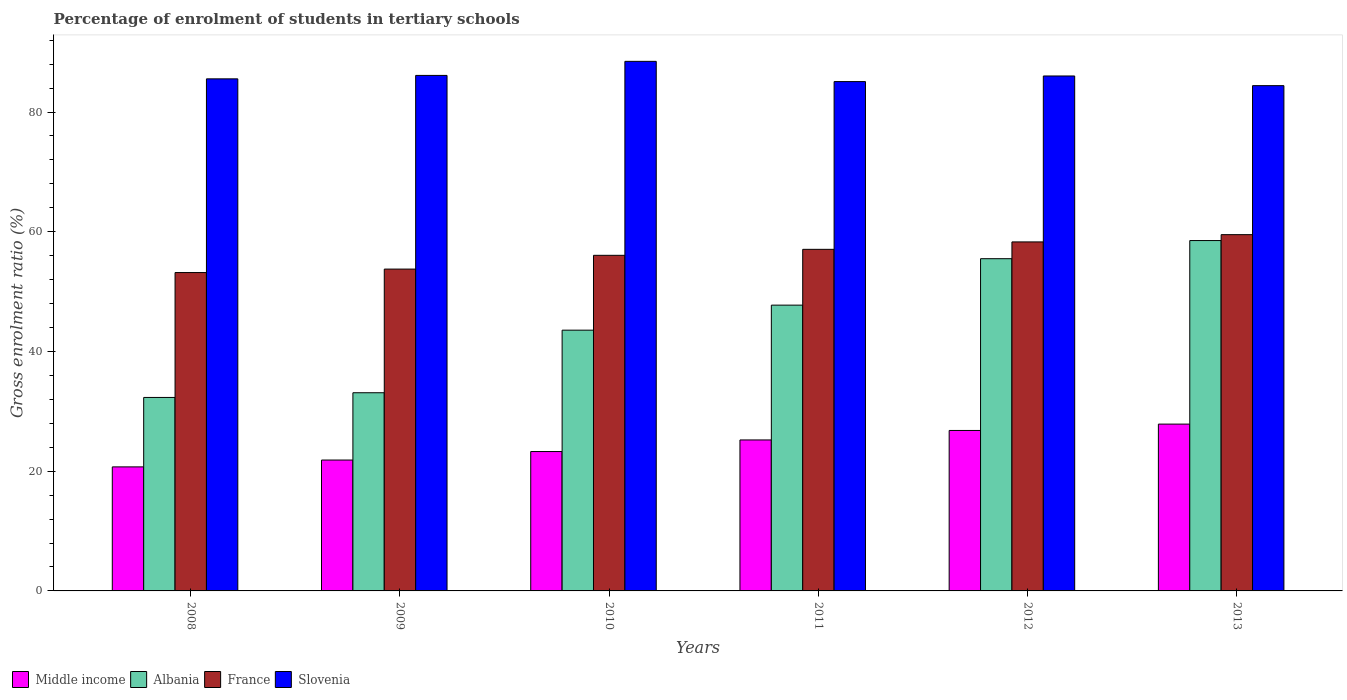How many different coloured bars are there?
Offer a terse response. 4. Are the number of bars per tick equal to the number of legend labels?
Offer a terse response. Yes. Are the number of bars on each tick of the X-axis equal?
Offer a very short reply. Yes. How many bars are there on the 2nd tick from the right?
Provide a short and direct response. 4. What is the label of the 6th group of bars from the left?
Make the answer very short. 2013. What is the percentage of students enrolled in tertiary schools in France in 2012?
Ensure brevity in your answer.  58.3. Across all years, what is the maximum percentage of students enrolled in tertiary schools in Middle income?
Offer a very short reply. 27.87. Across all years, what is the minimum percentage of students enrolled in tertiary schools in France?
Your answer should be very brief. 53.19. What is the total percentage of students enrolled in tertiary schools in Slovenia in the graph?
Give a very brief answer. 515.66. What is the difference between the percentage of students enrolled in tertiary schools in Middle income in 2011 and that in 2013?
Your response must be concise. -2.64. What is the difference between the percentage of students enrolled in tertiary schools in France in 2008 and the percentage of students enrolled in tertiary schools in Middle income in 2013?
Provide a succinct answer. 25.32. What is the average percentage of students enrolled in tertiary schools in Slovenia per year?
Your response must be concise. 85.94. In the year 2013, what is the difference between the percentage of students enrolled in tertiary schools in Albania and percentage of students enrolled in tertiary schools in France?
Ensure brevity in your answer.  -0.99. What is the ratio of the percentage of students enrolled in tertiary schools in Middle income in 2010 to that in 2012?
Provide a succinct answer. 0.87. Is the percentage of students enrolled in tertiary schools in Middle income in 2010 less than that in 2012?
Give a very brief answer. Yes. Is the difference between the percentage of students enrolled in tertiary schools in Albania in 2011 and 2013 greater than the difference between the percentage of students enrolled in tertiary schools in France in 2011 and 2013?
Provide a short and direct response. No. What is the difference between the highest and the second highest percentage of students enrolled in tertiary schools in France?
Your answer should be compact. 1.21. What is the difference between the highest and the lowest percentage of students enrolled in tertiary schools in Albania?
Your answer should be very brief. 26.21. In how many years, is the percentage of students enrolled in tertiary schools in France greater than the average percentage of students enrolled in tertiary schools in France taken over all years?
Your answer should be compact. 3. Is the sum of the percentage of students enrolled in tertiary schools in Middle income in 2010 and 2011 greater than the maximum percentage of students enrolled in tertiary schools in Slovenia across all years?
Provide a succinct answer. No. What does the 2nd bar from the left in 2013 represents?
Provide a short and direct response. Albania. What does the 4th bar from the right in 2012 represents?
Make the answer very short. Middle income. How many bars are there?
Offer a terse response. 24. Does the graph contain any zero values?
Provide a succinct answer. No. Does the graph contain grids?
Your response must be concise. No. Where does the legend appear in the graph?
Offer a terse response. Bottom left. How many legend labels are there?
Provide a short and direct response. 4. What is the title of the graph?
Provide a succinct answer. Percentage of enrolment of students in tertiary schools. Does "Qatar" appear as one of the legend labels in the graph?
Keep it short and to the point. No. What is the label or title of the Y-axis?
Offer a very short reply. Gross enrolment ratio (%). What is the Gross enrolment ratio (%) in Middle income in 2008?
Keep it short and to the point. 20.72. What is the Gross enrolment ratio (%) of Albania in 2008?
Keep it short and to the point. 32.32. What is the Gross enrolment ratio (%) of France in 2008?
Provide a short and direct response. 53.19. What is the Gross enrolment ratio (%) in Slovenia in 2008?
Provide a succinct answer. 85.55. What is the Gross enrolment ratio (%) in Middle income in 2009?
Offer a terse response. 21.86. What is the Gross enrolment ratio (%) of Albania in 2009?
Make the answer very short. 33.11. What is the Gross enrolment ratio (%) in France in 2009?
Offer a terse response. 53.76. What is the Gross enrolment ratio (%) of Slovenia in 2009?
Offer a very short reply. 86.12. What is the Gross enrolment ratio (%) in Middle income in 2010?
Keep it short and to the point. 23.28. What is the Gross enrolment ratio (%) of Albania in 2010?
Ensure brevity in your answer.  43.56. What is the Gross enrolment ratio (%) of France in 2010?
Offer a very short reply. 56.06. What is the Gross enrolment ratio (%) of Slovenia in 2010?
Provide a short and direct response. 88.47. What is the Gross enrolment ratio (%) of Middle income in 2011?
Provide a short and direct response. 25.22. What is the Gross enrolment ratio (%) in Albania in 2011?
Provide a succinct answer. 47.74. What is the Gross enrolment ratio (%) in France in 2011?
Provide a short and direct response. 57.06. What is the Gross enrolment ratio (%) in Slovenia in 2011?
Give a very brief answer. 85.09. What is the Gross enrolment ratio (%) in Middle income in 2012?
Provide a succinct answer. 26.81. What is the Gross enrolment ratio (%) in Albania in 2012?
Your response must be concise. 55.5. What is the Gross enrolment ratio (%) in France in 2012?
Your response must be concise. 58.3. What is the Gross enrolment ratio (%) in Slovenia in 2012?
Provide a succinct answer. 86.02. What is the Gross enrolment ratio (%) in Middle income in 2013?
Your response must be concise. 27.87. What is the Gross enrolment ratio (%) of Albania in 2013?
Make the answer very short. 58.53. What is the Gross enrolment ratio (%) of France in 2013?
Offer a terse response. 59.52. What is the Gross enrolment ratio (%) in Slovenia in 2013?
Keep it short and to the point. 84.41. Across all years, what is the maximum Gross enrolment ratio (%) of Middle income?
Your answer should be very brief. 27.87. Across all years, what is the maximum Gross enrolment ratio (%) in Albania?
Ensure brevity in your answer.  58.53. Across all years, what is the maximum Gross enrolment ratio (%) of France?
Ensure brevity in your answer.  59.52. Across all years, what is the maximum Gross enrolment ratio (%) of Slovenia?
Offer a very short reply. 88.47. Across all years, what is the minimum Gross enrolment ratio (%) in Middle income?
Make the answer very short. 20.72. Across all years, what is the minimum Gross enrolment ratio (%) in Albania?
Offer a terse response. 32.32. Across all years, what is the minimum Gross enrolment ratio (%) of France?
Your answer should be compact. 53.19. Across all years, what is the minimum Gross enrolment ratio (%) of Slovenia?
Provide a short and direct response. 84.41. What is the total Gross enrolment ratio (%) in Middle income in the graph?
Your answer should be very brief. 145.77. What is the total Gross enrolment ratio (%) of Albania in the graph?
Your answer should be compact. 270.76. What is the total Gross enrolment ratio (%) in France in the graph?
Provide a succinct answer. 337.9. What is the total Gross enrolment ratio (%) in Slovenia in the graph?
Provide a succinct answer. 515.66. What is the difference between the Gross enrolment ratio (%) in Middle income in 2008 and that in 2009?
Your answer should be compact. -1.14. What is the difference between the Gross enrolment ratio (%) in Albania in 2008 and that in 2009?
Offer a very short reply. -0.78. What is the difference between the Gross enrolment ratio (%) of France in 2008 and that in 2009?
Keep it short and to the point. -0.58. What is the difference between the Gross enrolment ratio (%) in Slovenia in 2008 and that in 2009?
Make the answer very short. -0.57. What is the difference between the Gross enrolment ratio (%) of Middle income in 2008 and that in 2010?
Make the answer very short. -2.56. What is the difference between the Gross enrolment ratio (%) in Albania in 2008 and that in 2010?
Give a very brief answer. -11.24. What is the difference between the Gross enrolment ratio (%) of France in 2008 and that in 2010?
Provide a succinct answer. -2.88. What is the difference between the Gross enrolment ratio (%) of Slovenia in 2008 and that in 2010?
Ensure brevity in your answer.  -2.92. What is the difference between the Gross enrolment ratio (%) of Middle income in 2008 and that in 2011?
Your answer should be very brief. -4.5. What is the difference between the Gross enrolment ratio (%) in Albania in 2008 and that in 2011?
Make the answer very short. -15.42. What is the difference between the Gross enrolment ratio (%) in France in 2008 and that in 2011?
Offer a very short reply. -3.88. What is the difference between the Gross enrolment ratio (%) of Slovenia in 2008 and that in 2011?
Provide a succinct answer. 0.46. What is the difference between the Gross enrolment ratio (%) in Middle income in 2008 and that in 2012?
Provide a short and direct response. -6.09. What is the difference between the Gross enrolment ratio (%) of Albania in 2008 and that in 2012?
Your response must be concise. -23.18. What is the difference between the Gross enrolment ratio (%) in France in 2008 and that in 2012?
Keep it short and to the point. -5.12. What is the difference between the Gross enrolment ratio (%) in Slovenia in 2008 and that in 2012?
Ensure brevity in your answer.  -0.48. What is the difference between the Gross enrolment ratio (%) of Middle income in 2008 and that in 2013?
Your response must be concise. -7.15. What is the difference between the Gross enrolment ratio (%) in Albania in 2008 and that in 2013?
Your answer should be very brief. -26.21. What is the difference between the Gross enrolment ratio (%) in France in 2008 and that in 2013?
Provide a succinct answer. -6.33. What is the difference between the Gross enrolment ratio (%) of Slovenia in 2008 and that in 2013?
Ensure brevity in your answer.  1.14. What is the difference between the Gross enrolment ratio (%) of Middle income in 2009 and that in 2010?
Give a very brief answer. -1.42. What is the difference between the Gross enrolment ratio (%) in Albania in 2009 and that in 2010?
Keep it short and to the point. -10.46. What is the difference between the Gross enrolment ratio (%) of France in 2009 and that in 2010?
Make the answer very short. -2.3. What is the difference between the Gross enrolment ratio (%) in Slovenia in 2009 and that in 2010?
Make the answer very short. -2.35. What is the difference between the Gross enrolment ratio (%) in Middle income in 2009 and that in 2011?
Provide a short and direct response. -3.36. What is the difference between the Gross enrolment ratio (%) in Albania in 2009 and that in 2011?
Your response must be concise. -14.64. What is the difference between the Gross enrolment ratio (%) in France in 2009 and that in 2011?
Offer a very short reply. -3.3. What is the difference between the Gross enrolment ratio (%) of Slovenia in 2009 and that in 2011?
Your response must be concise. 1.03. What is the difference between the Gross enrolment ratio (%) of Middle income in 2009 and that in 2012?
Offer a very short reply. -4.94. What is the difference between the Gross enrolment ratio (%) in Albania in 2009 and that in 2012?
Your response must be concise. -22.39. What is the difference between the Gross enrolment ratio (%) in France in 2009 and that in 2012?
Your answer should be very brief. -4.54. What is the difference between the Gross enrolment ratio (%) in Slovenia in 2009 and that in 2012?
Your answer should be compact. 0.09. What is the difference between the Gross enrolment ratio (%) in Middle income in 2009 and that in 2013?
Ensure brevity in your answer.  -6. What is the difference between the Gross enrolment ratio (%) in Albania in 2009 and that in 2013?
Make the answer very short. -25.42. What is the difference between the Gross enrolment ratio (%) of France in 2009 and that in 2013?
Your response must be concise. -5.75. What is the difference between the Gross enrolment ratio (%) of Slovenia in 2009 and that in 2013?
Offer a terse response. 1.71. What is the difference between the Gross enrolment ratio (%) of Middle income in 2010 and that in 2011?
Offer a very short reply. -1.94. What is the difference between the Gross enrolment ratio (%) in Albania in 2010 and that in 2011?
Offer a terse response. -4.18. What is the difference between the Gross enrolment ratio (%) in France in 2010 and that in 2011?
Keep it short and to the point. -1. What is the difference between the Gross enrolment ratio (%) in Slovenia in 2010 and that in 2011?
Make the answer very short. 3.38. What is the difference between the Gross enrolment ratio (%) of Middle income in 2010 and that in 2012?
Your answer should be compact. -3.52. What is the difference between the Gross enrolment ratio (%) in Albania in 2010 and that in 2012?
Offer a terse response. -11.94. What is the difference between the Gross enrolment ratio (%) of France in 2010 and that in 2012?
Ensure brevity in your answer.  -2.24. What is the difference between the Gross enrolment ratio (%) of Slovenia in 2010 and that in 2012?
Your response must be concise. 2.44. What is the difference between the Gross enrolment ratio (%) in Middle income in 2010 and that in 2013?
Your response must be concise. -4.58. What is the difference between the Gross enrolment ratio (%) in Albania in 2010 and that in 2013?
Offer a very short reply. -14.97. What is the difference between the Gross enrolment ratio (%) of France in 2010 and that in 2013?
Your answer should be compact. -3.45. What is the difference between the Gross enrolment ratio (%) of Slovenia in 2010 and that in 2013?
Your response must be concise. 4.06. What is the difference between the Gross enrolment ratio (%) of Middle income in 2011 and that in 2012?
Your response must be concise. -1.58. What is the difference between the Gross enrolment ratio (%) of Albania in 2011 and that in 2012?
Offer a terse response. -7.76. What is the difference between the Gross enrolment ratio (%) of France in 2011 and that in 2012?
Offer a terse response. -1.24. What is the difference between the Gross enrolment ratio (%) in Slovenia in 2011 and that in 2012?
Offer a terse response. -0.94. What is the difference between the Gross enrolment ratio (%) of Middle income in 2011 and that in 2013?
Your answer should be very brief. -2.64. What is the difference between the Gross enrolment ratio (%) in Albania in 2011 and that in 2013?
Your response must be concise. -10.79. What is the difference between the Gross enrolment ratio (%) of France in 2011 and that in 2013?
Provide a succinct answer. -2.45. What is the difference between the Gross enrolment ratio (%) in Slovenia in 2011 and that in 2013?
Provide a short and direct response. 0.68. What is the difference between the Gross enrolment ratio (%) in Middle income in 2012 and that in 2013?
Provide a short and direct response. -1.06. What is the difference between the Gross enrolment ratio (%) of Albania in 2012 and that in 2013?
Ensure brevity in your answer.  -3.03. What is the difference between the Gross enrolment ratio (%) of France in 2012 and that in 2013?
Provide a short and direct response. -1.21. What is the difference between the Gross enrolment ratio (%) of Slovenia in 2012 and that in 2013?
Your answer should be compact. 1.61. What is the difference between the Gross enrolment ratio (%) of Middle income in 2008 and the Gross enrolment ratio (%) of Albania in 2009?
Ensure brevity in your answer.  -12.39. What is the difference between the Gross enrolment ratio (%) of Middle income in 2008 and the Gross enrolment ratio (%) of France in 2009?
Your answer should be very brief. -33.04. What is the difference between the Gross enrolment ratio (%) of Middle income in 2008 and the Gross enrolment ratio (%) of Slovenia in 2009?
Provide a short and direct response. -65.4. What is the difference between the Gross enrolment ratio (%) of Albania in 2008 and the Gross enrolment ratio (%) of France in 2009?
Ensure brevity in your answer.  -21.44. What is the difference between the Gross enrolment ratio (%) of Albania in 2008 and the Gross enrolment ratio (%) of Slovenia in 2009?
Your answer should be very brief. -53.8. What is the difference between the Gross enrolment ratio (%) of France in 2008 and the Gross enrolment ratio (%) of Slovenia in 2009?
Provide a short and direct response. -32.93. What is the difference between the Gross enrolment ratio (%) in Middle income in 2008 and the Gross enrolment ratio (%) in Albania in 2010?
Provide a short and direct response. -22.84. What is the difference between the Gross enrolment ratio (%) of Middle income in 2008 and the Gross enrolment ratio (%) of France in 2010?
Give a very brief answer. -35.34. What is the difference between the Gross enrolment ratio (%) of Middle income in 2008 and the Gross enrolment ratio (%) of Slovenia in 2010?
Provide a succinct answer. -67.75. What is the difference between the Gross enrolment ratio (%) of Albania in 2008 and the Gross enrolment ratio (%) of France in 2010?
Your answer should be very brief. -23.74. What is the difference between the Gross enrolment ratio (%) in Albania in 2008 and the Gross enrolment ratio (%) in Slovenia in 2010?
Provide a succinct answer. -56.15. What is the difference between the Gross enrolment ratio (%) in France in 2008 and the Gross enrolment ratio (%) in Slovenia in 2010?
Offer a terse response. -35.28. What is the difference between the Gross enrolment ratio (%) of Middle income in 2008 and the Gross enrolment ratio (%) of Albania in 2011?
Keep it short and to the point. -27.02. What is the difference between the Gross enrolment ratio (%) of Middle income in 2008 and the Gross enrolment ratio (%) of France in 2011?
Your response must be concise. -36.34. What is the difference between the Gross enrolment ratio (%) of Middle income in 2008 and the Gross enrolment ratio (%) of Slovenia in 2011?
Give a very brief answer. -64.37. What is the difference between the Gross enrolment ratio (%) of Albania in 2008 and the Gross enrolment ratio (%) of France in 2011?
Ensure brevity in your answer.  -24.74. What is the difference between the Gross enrolment ratio (%) in Albania in 2008 and the Gross enrolment ratio (%) in Slovenia in 2011?
Ensure brevity in your answer.  -52.77. What is the difference between the Gross enrolment ratio (%) of France in 2008 and the Gross enrolment ratio (%) of Slovenia in 2011?
Your answer should be very brief. -31.9. What is the difference between the Gross enrolment ratio (%) of Middle income in 2008 and the Gross enrolment ratio (%) of Albania in 2012?
Your response must be concise. -34.78. What is the difference between the Gross enrolment ratio (%) of Middle income in 2008 and the Gross enrolment ratio (%) of France in 2012?
Ensure brevity in your answer.  -37.58. What is the difference between the Gross enrolment ratio (%) of Middle income in 2008 and the Gross enrolment ratio (%) of Slovenia in 2012?
Provide a short and direct response. -65.3. What is the difference between the Gross enrolment ratio (%) in Albania in 2008 and the Gross enrolment ratio (%) in France in 2012?
Ensure brevity in your answer.  -25.98. What is the difference between the Gross enrolment ratio (%) of Albania in 2008 and the Gross enrolment ratio (%) of Slovenia in 2012?
Offer a very short reply. -53.7. What is the difference between the Gross enrolment ratio (%) of France in 2008 and the Gross enrolment ratio (%) of Slovenia in 2012?
Give a very brief answer. -32.84. What is the difference between the Gross enrolment ratio (%) of Middle income in 2008 and the Gross enrolment ratio (%) of Albania in 2013?
Make the answer very short. -37.81. What is the difference between the Gross enrolment ratio (%) in Middle income in 2008 and the Gross enrolment ratio (%) in France in 2013?
Your answer should be very brief. -38.8. What is the difference between the Gross enrolment ratio (%) of Middle income in 2008 and the Gross enrolment ratio (%) of Slovenia in 2013?
Give a very brief answer. -63.69. What is the difference between the Gross enrolment ratio (%) of Albania in 2008 and the Gross enrolment ratio (%) of France in 2013?
Provide a short and direct response. -27.2. What is the difference between the Gross enrolment ratio (%) of Albania in 2008 and the Gross enrolment ratio (%) of Slovenia in 2013?
Offer a terse response. -52.09. What is the difference between the Gross enrolment ratio (%) of France in 2008 and the Gross enrolment ratio (%) of Slovenia in 2013?
Your answer should be very brief. -31.22. What is the difference between the Gross enrolment ratio (%) of Middle income in 2009 and the Gross enrolment ratio (%) of Albania in 2010?
Keep it short and to the point. -21.7. What is the difference between the Gross enrolment ratio (%) of Middle income in 2009 and the Gross enrolment ratio (%) of France in 2010?
Make the answer very short. -34.2. What is the difference between the Gross enrolment ratio (%) of Middle income in 2009 and the Gross enrolment ratio (%) of Slovenia in 2010?
Ensure brevity in your answer.  -66.6. What is the difference between the Gross enrolment ratio (%) of Albania in 2009 and the Gross enrolment ratio (%) of France in 2010?
Keep it short and to the point. -22.96. What is the difference between the Gross enrolment ratio (%) in Albania in 2009 and the Gross enrolment ratio (%) in Slovenia in 2010?
Your answer should be very brief. -55.36. What is the difference between the Gross enrolment ratio (%) of France in 2009 and the Gross enrolment ratio (%) of Slovenia in 2010?
Ensure brevity in your answer.  -34.7. What is the difference between the Gross enrolment ratio (%) in Middle income in 2009 and the Gross enrolment ratio (%) in Albania in 2011?
Your answer should be compact. -25.88. What is the difference between the Gross enrolment ratio (%) in Middle income in 2009 and the Gross enrolment ratio (%) in France in 2011?
Give a very brief answer. -35.2. What is the difference between the Gross enrolment ratio (%) of Middle income in 2009 and the Gross enrolment ratio (%) of Slovenia in 2011?
Offer a very short reply. -63.22. What is the difference between the Gross enrolment ratio (%) in Albania in 2009 and the Gross enrolment ratio (%) in France in 2011?
Your response must be concise. -23.96. What is the difference between the Gross enrolment ratio (%) of Albania in 2009 and the Gross enrolment ratio (%) of Slovenia in 2011?
Offer a very short reply. -51.98. What is the difference between the Gross enrolment ratio (%) in France in 2009 and the Gross enrolment ratio (%) in Slovenia in 2011?
Offer a very short reply. -31.32. What is the difference between the Gross enrolment ratio (%) of Middle income in 2009 and the Gross enrolment ratio (%) of Albania in 2012?
Provide a short and direct response. -33.64. What is the difference between the Gross enrolment ratio (%) of Middle income in 2009 and the Gross enrolment ratio (%) of France in 2012?
Your response must be concise. -36.44. What is the difference between the Gross enrolment ratio (%) of Middle income in 2009 and the Gross enrolment ratio (%) of Slovenia in 2012?
Make the answer very short. -64.16. What is the difference between the Gross enrolment ratio (%) in Albania in 2009 and the Gross enrolment ratio (%) in France in 2012?
Ensure brevity in your answer.  -25.2. What is the difference between the Gross enrolment ratio (%) in Albania in 2009 and the Gross enrolment ratio (%) in Slovenia in 2012?
Offer a very short reply. -52.92. What is the difference between the Gross enrolment ratio (%) in France in 2009 and the Gross enrolment ratio (%) in Slovenia in 2012?
Provide a succinct answer. -32.26. What is the difference between the Gross enrolment ratio (%) in Middle income in 2009 and the Gross enrolment ratio (%) in Albania in 2013?
Keep it short and to the point. -36.67. What is the difference between the Gross enrolment ratio (%) of Middle income in 2009 and the Gross enrolment ratio (%) of France in 2013?
Ensure brevity in your answer.  -37.65. What is the difference between the Gross enrolment ratio (%) in Middle income in 2009 and the Gross enrolment ratio (%) in Slovenia in 2013?
Offer a very short reply. -62.55. What is the difference between the Gross enrolment ratio (%) of Albania in 2009 and the Gross enrolment ratio (%) of France in 2013?
Give a very brief answer. -26.41. What is the difference between the Gross enrolment ratio (%) of Albania in 2009 and the Gross enrolment ratio (%) of Slovenia in 2013?
Provide a succinct answer. -51.3. What is the difference between the Gross enrolment ratio (%) of France in 2009 and the Gross enrolment ratio (%) of Slovenia in 2013?
Offer a terse response. -30.65. What is the difference between the Gross enrolment ratio (%) in Middle income in 2010 and the Gross enrolment ratio (%) in Albania in 2011?
Keep it short and to the point. -24.46. What is the difference between the Gross enrolment ratio (%) of Middle income in 2010 and the Gross enrolment ratio (%) of France in 2011?
Ensure brevity in your answer.  -33.78. What is the difference between the Gross enrolment ratio (%) in Middle income in 2010 and the Gross enrolment ratio (%) in Slovenia in 2011?
Provide a short and direct response. -61.8. What is the difference between the Gross enrolment ratio (%) of Albania in 2010 and the Gross enrolment ratio (%) of France in 2011?
Make the answer very short. -13.5. What is the difference between the Gross enrolment ratio (%) in Albania in 2010 and the Gross enrolment ratio (%) in Slovenia in 2011?
Your response must be concise. -41.53. What is the difference between the Gross enrolment ratio (%) of France in 2010 and the Gross enrolment ratio (%) of Slovenia in 2011?
Keep it short and to the point. -29.03. What is the difference between the Gross enrolment ratio (%) in Middle income in 2010 and the Gross enrolment ratio (%) in Albania in 2012?
Your answer should be very brief. -32.22. What is the difference between the Gross enrolment ratio (%) of Middle income in 2010 and the Gross enrolment ratio (%) of France in 2012?
Give a very brief answer. -35.02. What is the difference between the Gross enrolment ratio (%) of Middle income in 2010 and the Gross enrolment ratio (%) of Slovenia in 2012?
Offer a very short reply. -62.74. What is the difference between the Gross enrolment ratio (%) of Albania in 2010 and the Gross enrolment ratio (%) of France in 2012?
Offer a terse response. -14.74. What is the difference between the Gross enrolment ratio (%) in Albania in 2010 and the Gross enrolment ratio (%) in Slovenia in 2012?
Your answer should be compact. -42.46. What is the difference between the Gross enrolment ratio (%) of France in 2010 and the Gross enrolment ratio (%) of Slovenia in 2012?
Give a very brief answer. -29.96. What is the difference between the Gross enrolment ratio (%) of Middle income in 2010 and the Gross enrolment ratio (%) of Albania in 2013?
Give a very brief answer. -35.25. What is the difference between the Gross enrolment ratio (%) in Middle income in 2010 and the Gross enrolment ratio (%) in France in 2013?
Your answer should be compact. -36.23. What is the difference between the Gross enrolment ratio (%) of Middle income in 2010 and the Gross enrolment ratio (%) of Slovenia in 2013?
Offer a terse response. -61.13. What is the difference between the Gross enrolment ratio (%) of Albania in 2010 and the Gross enrolment ratio (%) of France in 2013?
Make the answer very short. -15.96. What is the difference between the Gross enrolment ratio (%) of Albania in 2010 and the Gross enrolment ratio (%) of Slovenia in 2013?
Your answer should be very brief. -40.85. What is the difference between the Gross enrolment ratio (%) in France in 2010 and the Gross enrolment ratio (%) in Slovenia in 2013?
Your answer should be very brief. -28.35. What is the difference between the Gross enrolment ratio (%) in Middle income in 2011 and the Gross enrolment ratio (%) in Albania in 2012?
Your answer should be compact. -30.28. What is the difference between the Gross enrolment ratio (%) in Middle income in 2011 and the Gross enrolment ratio (%) in France in 2012?
Provide a succinct answer. -33.08. What is the difference between the Gross enrolment ratio (%) in Middle income in 2011 and the Gross enrolment ratio (%) in Slovenia in 2012?
Make the answer very short. -60.8. What is the difference between the Gross enrolment ratio (%) of Albania in 2011 and the Gross enrolment ratio (%) of France in 2012?
Provide a short and direct response. -10.56. What is the difference between the Gross enrolment ratio (%) of Albania in 2011 and the Gross enrolment ratio (%) of Slovenia in 2012?
Provide a short and direct response. -38.28. What is the difference between the Gross enrolment ratio (%) in France in 2011 and the Gross enrolment ratio (%) in Slovenia in 2012?
Your answer should be compact. -28.96. What is the difference between the Gross enrolment ratio (%) of Middle income in 2011 and the Gross enrolment ratio (%) of Albania in 2013?
Provide a succinct answer. -33.31. What is the difference between the Gross enrolment ratio (%) in Middle income in 2011 and the Gross enrolment ratio (%) in France in 2013?
Your answer should be very brief. -34.3. What is the difference between the Gross enrolment ratio (%) of Middle income in 2011 and the Gross enrolment ratio (%) of Slovenia in 2013?
Offer a terse response. -59.19. What is the difference between the Gross enrolment ratio (%) of Albania in 2011 and the Gross enrolment ratio (%) of France in 2013?
Provide a succinct answer. -11.78. What is the difference between the Gross enrolment ratio (%) in Albania in 2011 and the Gross enrolment ratio (%) in Slovenia in 2013?
Your answer should be compact. -36.67. What is the difference between the Gross enrolment ratio (%) of France in 2011 and the Gross enrolment ratio (%) of Slovenia in 2013?
Give a very brief answer. -27.35. What is the difference between the Gross enrolment ratio (%) in Middle income in 2012 and the Gross enrolment ratio (%) in Albania in 2013?
Ensure brevity in your answer.  -31.72. What is the difference between the Gross enrolment ratio (%) of Middle income in 2012 and the Gross enrolment ratio (%) of France in 2013?
Give a very brief answer. -32.71. What is the difference between the Gross enrolment ratio (%) in Middle income in 2012 and the Gross enrolment ratio (%) in Slovenia in 2013?
Your answer should be compact. -57.6. What is the difference between the Gross enrolment ratio (%) in Albania in 2012 and the Gross enrolment ratio (%) in France in 2013?
Keep it short and to the point. -4.02. What is the difference between the Gross enrolment ratio (%) of Albania in 2012 and the Gross enrolment ratio (%) of Slovenia in 2013?
Your answer should be very brief. -28.91. What is the difference between the Gross enrolment ratio (%) in France in 2012 and the Gross enrolment ratio (%) in Slovenia in 2013?
Your response must be concise. -26.1. What is the average Gross enrolment ratio (%) of Middle income per year?
Your answer should be very brief. 24.29. What is the average Gross enrolment ratio (%) of Albania per year?
Your answer should be very brief. 45.13. What is the average Gross enrolment ratio (%) in France per year?
Offer a very short reply. 56.32. What is the average Gross enrolment ratio (%) in Slovenia per year?
Provide a succinct answer. 85.94. In the year 2008, what is the difference between the Gross enrolment ratio (%) in Middle income and Gross enrolment ratio (%) in Albania?
Your answer should be compact. -11.6. In the year 2008, what is the difference between the Gross enrolment ratio (%) in Middle income and Gross enrolment ratio (%) in France?
Your response must be concise. -32.47. In the year 2008, what is the difference between the Gross enrolment ratio (%) in Middle income and Gross enrolment ratio (%) in Slovenia?
Provide a short and direct response. -64.83. In the year 2008, what is the difference between the Gross enrolment ratio (%) of Albania and Gross enrolment ratio (%) of France?
Your answer should be very brief. -20.86. In the year 2008, what is the difference between the Gross enrolment ratio (%) in Albania and Gross enrolment ratio (%) in Slovenia?
Provide a short and direct response. -53.22. In the year 2008, what is the difference between the Gross enrolment ratio (%) of France and Gross enrolment ratio (%) of Slovenia?
Offer a terse response. -32.36. In the year 2009, what is the difference between the Gross enrolment ratio (%) of Middle income and Gross enrolment ratio (%) of Albania?
Your response must be concise. -11.24. In the year 2009, what is the difference between the Gross enrolment ratio (%) of Middle income and Gross enrolment ratio (%) of France?
Your answer should be compact. -31.9. In the year 2009, what is the difference between the Gross enrolment ratio (%) in Middle income and Gross enrolment ratio (%) in Slovenia?
Give a very brief answer. -64.25. In the year 2009, what is the difference between the Gross enrolment ratio (%) in Albania and Gross enrolment ratio (%) in France?
Offer a terse response. -20.66. In the year 2009, what is the difference between the Gross enrolment ratio (%) of Albania and Gross enrolment ratio (%) of Slovenia?
Keep it short and to the point. -53.01. In the year 2009, what is the difference between the Gross enrolment ratio (%) in France and Gross enrolment ratio (%) in Slovenia?
Your answer should be very brief. -32.35. In the year 2010, what is the difference between the Gross enrolment ratio (%) in Middle income and Gross enrolment ratio (%) in Albania?
Provide a short and direct response. -20.28. In the year 2010, what is the difference between the Gross enrolment ratio (%) in Middle income and Gross enrolment ratio (%) in France?
Provide a short and direct response. -32.78. In the year 2010, what is the difference between the Gross enrolment ratio (%) of Middle income and Gross enrolment ratio (%) of Slovenia?
Offer a terse response. -65.18. In the year 2010, what is the difference between the Gross enrolment ratio (%) in Albania and Gross enrolment ratio (%) in France?
Offer a terse response. -12.5. In the year 2010, what is the difference between the Gross enrolment ratio (%) in Albania and Gross enrolment ratio (%) in Slovenia?
Keep it short and to the point. -44.91. In the year 2010, what is the difference between the Gross enrolment ratio (%) in France and Gross enrolment ratio (%) in Slovenia?
Give a very brief answer. -32.4. In the year 2011, what is the difference between the Gross enrolment ratio (%) in Middle income and Gross enrolment ratio (%) in Albania?
Ensure brevity in your answer.  -22.52. In the year 2011, what is the difference between the Gross enrolment ratio (%) of Middle income and Gross enrolment ratio (%) of France?
Your response must be concise. -31.84. In the year 2011, what is the difference between the Gross enrolment ratio (%) in Middle income and Gross enrolment ratio (%) in Slovenia?
Your answer should be very brief. -59.87. In the year 2011, what is the difference between the Gross enrolment ratio (%) in Albania and Gross enrolment ratio (%) in France?
Your answer should be compact. -9.32. In the year 2011, what is the difference between the Gross enrolment ratio (%) in Albania and Gross enrolment ratio (%) in Slovenia?
Give a very brief answer. -37.35. In the year 2011, what is the difference between the Gross enrolment ratio (%) of France and Gross enrolment ratio (%) of Slovenia?
Your answer should be very brief. -28.03. In the year 2012, what is the difference between the Gross enrolment ratio (%) in Middle income and Gross enrolment ratio (%) in Albania?
Offer a very short reply. -28.69. In the year 2012, what is the difference between the Gross enrolment ratio (%) of Middle income and Gross enrolment ratio (%) of France?
Give a very brief answer. -31.5. In the year 2012, what is the difference between the Gross enrolment ratio (%) of Middle income and Gross enrolment ratio (%) of Slovenia?
Your answer should be compact. -59.22. In the year 2012, what is the difference between the Gross enrolment ratio (%) of Albania and Gross enrolment ratio (%) of France?
Make the answer very short. -2.8. In the year 2012, what is the difference between the Gross enrolment ratio (%) of Albania and Gross enrolment ratio (%) of Slovenia?
Give a very brief answer. -30.52. In the year 2012, what is the difference between the Gross enrolment ratio (%) of France and Gross enrolment ratio (%) of Slovenia?
Make the answer very short. -27.72. In the year 2013, what is the difference between the Gross enrolment ratio (%) of Middle income and Gross enrolment ratio (%) of Albania?
Offer a terse response. -30.66. In the year 2013, what is the difference between the Gross enrolment ratio (%) in Middle income and Gross enrolment ratio (%) in France?
Keep it short and to the point. -31.65. In the year 2013, what is the difference between the Gross enrolment ratio (%) of Middle income and Gross enrolment ratio (%) of Slovenia?
Provide a succinct answer. -56.54. In the year 2013, what is the difference between the Gross enrolment ratio (%) in Albania and Gross enrolment ratio (%) in France?
Ensure brevity in your answer.  -0.99. In the year 2013, what is the difference between the Gross enrolment ratio (%) in Albania and Gross enrolment ratio (%) in Slovenia?
Keep it short and to the point. -25.88. In the year 2013, what is the difference between the Gross enrolment ratio (%) of France and Gross enrolment ratio (%) of Slovenia?
Provide a succinct answer. -24.89. What is the ratio of the Gross enrolment ratio (%) in Middle income in 2008 to that in 2009?
Keep it short and to the point. 0.95. What is the ratio of the Gross enrolment ratio (%) in Albania in 2008 to that in 2009?
Provide a short and direct response. 0.98. What is the ratio of the Gross enrolment ratio (%) in France in 2008 to that in 2009?
Your answer should be compact. 0.99. What is the ratio of the Gross enrolment ratio (%) of Slovenia in 2008 to that in 2009?
Your answer should be compact. 0.99. What is the ratio of the Gross enrolment ratio (%) of Middle income in 2008 to that in 2010?
Offer a terse response. 0.89. What is the ratio of the Gross enrolment ratio (%) in Albania in 2008 to that in 2010?
Ensure brevity in your answer.  0.74. What is the ratio of the Gross enrolment ratio (%) of France in 2008 to that in 2010?
Offer a very short reply. 0.95. What is the ratio of the Gross enrolment ratio (%) of Slovenia in 2008 to that in 2010?
Your response must be concise. 0.97. What is the ratio of the Gross enrolment ratio (%) in Middle income in 2008 to that in 2011?
Offer a terse response. 0.82. What is the ratio of the Gross enrolment ratio (%) in Albania in 2008 to that in 2011?
Provide a succinct answer. 0.68. What is the ratio of the Gross enrolment ratio (%) in France in 2008 to that in 2011?
Make the answer very short. 0.93. What is the ratio of the Gross enrolment ratio (%) of Slovenia in 2008 to that in 2011?
Offer a very short reply. 1.01. What is the ratio of the Gross enrolment ratio (%) in Middle income in 2008 to that in 2012?
Provide a succinct answer. 0.77. What is the ratio of the Gross enrolment ratio (%) in Albania in 2008 to that in 2012?
Provide a succinct answer. 0.58. What is the ratio of the Gross enrolment ratio (%) of France in 2008 to that in 2012?
Your answer should be very brief. 0.91. What is the ratio of the Gross enrolment ratio (%) of Slovenia in 2008 to that in 2012?
Make the answer very short. 0.99. What is the ratio of the Gross enrolment ratio (%) in Middle income in 2008 to that in 2013?
Your response must be concise. 0.74. What is the ratio of the Gross enrolment ratio (%) of Albania in 2008 to that in 2013?
Offer a terse response. 0.55. What is the ratio of the Gross enrolment ratio (%) of France in 2008 to that in 2013?
Your answer should be very brief. 0.89. What is the ratio of the Gross enrolment ratio (%) of Slovenia in 2008 to that in 2013?
Your answer should be compact. 1.01. What is the ratio of the Gross enrolment ratio (%) in Middle income in 2009 to that in 2010?
Your answer should be compact. 0.94. What is the ratio of the Gross enrolment ratio (%) of Albania in 2009 to that in 2010?
Provide a succinct answer. 0.76. What is the ratio of the Gross enrolment ratio (%) in France in 2009 to that in 2010?
Your response must be concise. 0.96. What is the ratio of the Gross enrolment ratio (%) in Slovenia in 2009 to that in 2010?
Your answer should be compact. 0.97. What is the ratio of the Gross enrolment ratio (%) in Middle income in 2009 to that in 2011?
Ensure brevity in your answer.  0.87. What is the ratio of the Gross enrolment ratio (%) in Albania in 2009 to that in 2011?
Give a very brief answer. 0.69. What is the ratio of the Gross enrolment ratio (%) in France in 2009 to that in 2011?
Provide a short and direct response. 0.94. What is the ratio of the Gross enrolment ratio (%) of Slovenia in 2009 to that in 2011?
Give a very brief answer. 1.01. What is the ratio of the Gross enrolment ratio (%) in Middle income in 2009 to that in 2012?
Offer a terse response. 0.82. What is the ratio of the Gross enrolment ratio (%) in Albania in 2009 to that in 2012?
Your answer should be very brief. 0.6. What is the ratio of the Gross enrolment ratio (%) of France in 2009 to that in 2012?
Your answer should be compact. 0.92. What is the ratio of the Gross enrolment ratio (%) of Middle income in 2009 to that in 2013?
Keep it short and to the point. 0.78. What is the ratio of the Gross enrolment ratio (%) of Albania in 2009 to that in 2013?
Provide a short and direct response. 0.57. What is the ratio of the Gross enrolment ratio (%) of France in 2009 to that in 2013?
Make the answer very short. 0.9. What is the ratio of the Gross enrolment ratio (%) in Slovenia in 2009 to that in 2013?
Your answer should be compact. 1.02. What is the ratio of the Gross enrolment ratio (%) in Middle income in 2010 to that in 2011?
Your answer should be compact. 0.92. What is the ratio of the Gross enrolment ratio (%) in Albania in 2010 to that in 2011?
Your answer should be very brief. 0.91. What is the ratio of the Gross enrolment ratio (%) in France in 2010 to that in 2011?
Provide a short and direct response. 0.98. What is the ratio of the Gross enrolment ratio (%) of Slovenia in 2010 to that in 2011?
Your response must be concise. 1.04. What is the ratio of the Gross enrolment ratio (%) in Middle income in 2010 to that in 2012?
Provide a short and direct response. 0.87. What is the ratio of the Gross enrolment ratio (%) of Albania in 2010 to that in 2012?
Make the answer very short. 0.78. What is the ratio of the Gross enrolment ratio (%) in France in 2010 to that in 2012?
Give a very brief answer. 0.96. What is the ratio of the Gross enrolment ratio (%) in Slovenia in 2010 to that in 2012?
Your answer should be compact. 1.03. What is the ratio of the Gross enrolment ratio (%) in Middle income in 2010 to that in 2013?
Offer a very short reply. 0.84. What is the ratio of the Gross enrolment ratio (%) of Albania in 2010 to that in 2013?
Your answer should be compact. 0.74. What is the ratio of the Gross enrolment ratio (%) in France in 2010 to that in 2013?
Your response must be concise. 0.94. What is the ratio of the Gross enrolment ratio (%) of Slovenia in 2010 to that in 2013?
Your response must be concise. 1.05. What is the ratio of the Gross enrolment ratio (%) in Middle income in 2011 to that in 2012?
Your answer should be very brief. 0.94. What is the ratio of the Gross enrolment ratio (%) of Albania in 2011 to that in 2012?
Your answer should be compact. 0.86. What is the ratio of the Gross enrolment ratio (%) in France in 2011 to that in 2012?
Your response must be concise. 0.98. What is the ratio of the Gross enrolment ratio (%) of Middle income in 2011 to that in 2013?
Your response must be concise. 0.91. What is the ratio of the Gross enrolment ratio (%) of Albania in 2011 to that in 2013?
Ensure brevity in your answer.  0.82. What is the ratio of the Gross enrolment ratio (%) in France in 2011 to that in 2013?
Provide a short and direct response. 0.96. What is the ratio of the Gross enrolment ratio (%) of Slovenia in 2011 to that in 2013?
Your answer should be compact. 1.01. What is the ratio of the Gross enrolment ratio (%) of Middle income in 2012 to that in 2013?
Offer a terse response. 0.96. What is the ratio of the Gross enrolment ratio (%) in Albania in 2012 to that in 2013?
Make the answer very short. 0.95. What is the ratio of the Gross enrolment ratio (%) of France in 2012 to that in 2013?
Make the answer very short. 0.98. What is the ratio of the Gross enrolment ratio (%) of Slovenia in 2012 to that in 2013?
Your answer should be very brief. 1.02. What is the difference between the highest and the second highest Gross enrolment ratio (%) in Middle income?
Provide a succinct answer. 1.06. What is the difference between the highest and the second highest Gross enrolment ratio (%) in Albania?
Offer a terse response. 3.03. What is the difference between the highest and the second highest Gross enrolment ratio (%) in France?
Your answer should be compact. 1.21. What is the difference between the highest and the second highest Gross enrolment ratio (%) of Slovenia?
Keep it short and to the point. 2.35. What is the difference between the highest and the lowest Gross enrolment ratio (%) in Middle income?
Provide a short and direct response. 7.15. What is the difference between the highest and the lowest Gross enrolment ratio (%) in Albania?
Your response must be concise. 26.21. What is the difference between the highest and the lowest Gross enrolment ratio (%) in France?
Your answer should be very brief. 6.33. What is the difference between the highest and the lowest Gross enrolment ratio (%) in Slovenia?
Your response must be concise. 4.06. 